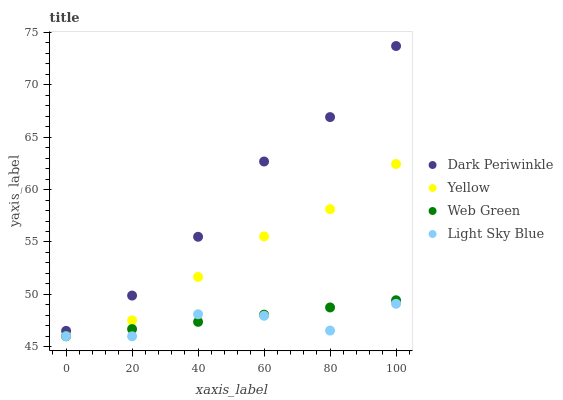Does Light Sky Blue have the minimum area under the curve?
Answer yes or no. Yes. Does Dark Periwinkle have the maximum area under the curve?
Answer yes or no. Yes. Does Yellow have the minimum area under the curve?
Answer yes or no. No. Does Yellow have the maximum area under the curve?
Answer yes or no. No. Is Web Green the smoothest?
Answer yes or no. Yes. Is Light Sky Blue the roughest?
Answer yes or no. Yes. Is Dark Periwinkle the smoothest?
Answer yes or no. No. Is Dark Periwinkle the roughest?
Answer yes or no. No. Does Web Green have the lowest value?
Answer yes or no. Yes. Does Dark Periwinkle have the lowest value?
Answer yes or no. No. Does Dark Periwinkle have the highest value?
Answer yes or no. Yes. Does Yellow have the highest value?
Answer yes or no. No. Is Light Sky Blue less than Dark Periwinkle?
Answer yes or no. Yes. Is Dark Periwinkle greater than Yellow?
Answer yes or no. Yes. Does Web Green intersect Light Sky Blue?
Answer yes or no. Yes. Is Web Green less than Light Sky Blue?
Answer yes or no. No. Is Web Green greater than Light Sky Blue?
Answer yes or no. No. Does Light Sky Blue intersect Dark Periwinkle?
Answer yes or no. No. 